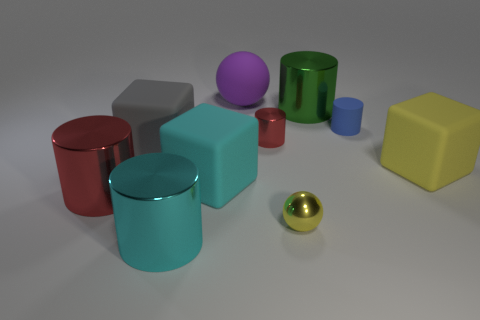Is there a yellow object that has the same shape as the large cyan rubber thing?
Offer a terse response. Yes. The sphere that is the same size as the gray rubber object is what color?
Offer a very short reply. Purple. There is a tiny cylinder that is to the left of the yellow metal sphere; what is its material?
Your response must be concise. Metal. Does the matte object behind the blue object have the same shape as the tiny metal thing in front of the gray block?
Provide a succinct answer. Yes. Are there an equal number of blue cylinders that are on the right side of the blue thing and small yellow objects?
Make the answer very short. No. How many tiny yellow things are made of the same material as the tiny blue cylinder?
Keep it short and to the point. 0. There is a large ball that is made of the same material as the tiny blue cylinder; what is its color?
Your answer should be very brief. Purple. Do the yellow rubber block and the red shiny cylinder left of the gray object have the same size?
Keep it short and to the point. Yes. The cyan matte thing has what shape?
Your response must be concise. Cube. How many things have the same color as the metallic ball?
Your response must be concise. 1. 